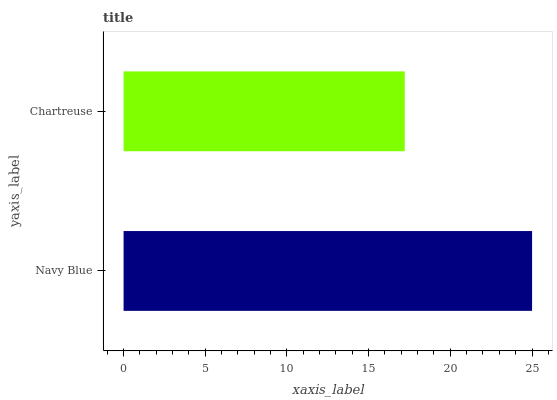Is Chartreuse the minimum?
Answer yes or no. Yes. Is Navy Blue the maximum?
Answer yes or no. Yes. Is Chartreuse the maximum?
Answer yes or no. No. Is Navy Blue greater than Chartreuse?
Answer yes or no. Yes. Is Chartreuse less than Navy Blue?
Answer yes or no. Yes. Is Chartreuse greater than Navy Blue?
Answer yes or no. No. Is Navy Blue less than Chartreuse?
Answer yes or no. No. Is Navy Blue the high median?
Answer yes or no. Yes. Is Chartreuse the low median?
Answer yes or no. Yes. Is Chartreuse the high median?
Answer yes or no. No. Is Navy Blue the low median?
Answer yes or no. No. 